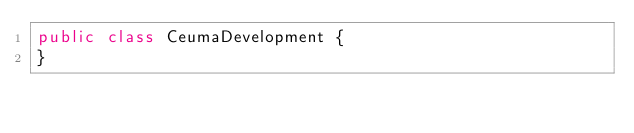Convert code to text. <code><loc_0><loc_0><loc_500><loc_500><_Java_>public class CeumaDevelopment {
}
</code> 